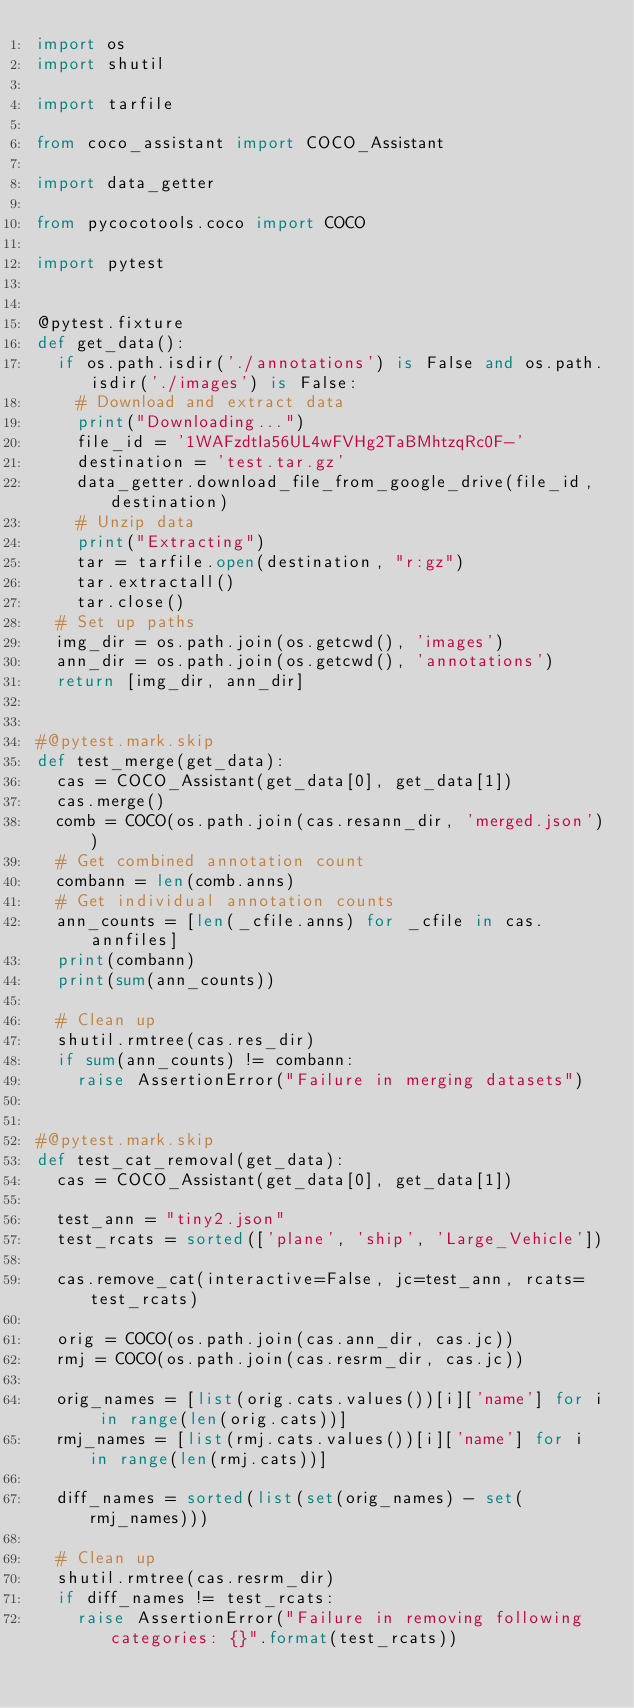<code> <loc_0><loc_0><loc_500><loc_500><_Python_>import os
import shutil

import tarfile

from coco_assistant import COCO_Assistant

import data_getter

from pycocotools.coco import COCO

import pytest


@pytest.fixture
def get_data():
	if os.path.isdir('./annotations') is False and os.path.isdir('./images') is False:
		# Download and extract data
		print("Downloading...")
		file_id = '1WAFzdtIa56UL4wFVHg2TaBMhtzqRc0F-'
		destination = 'test.tar.gz'
		data_getter.download_file_from_google_drive(file_id, destination)
		# Unzip data
		print("Extracting")
		tar = tarfile.open(destination, "r:gz")
		tar.extractall()
		tar.close()
	# Set up paths
	img_dir = os.path.join(os.getcwd(), 'images')
	ann_dir = os.path.join(os.getcwd(), 'annotations')
	return [img_dir, ann_dir]


#@pytest.mark.skip
def test_merge(get_data):
	cas = COCO_Assistant(get_data[0], get_data[1])
	cas.merge()
	comb = COCO(os.path.join(cas.resann_dir, 'merged.json'))
	# Get combined annotation count
	combann = len(comb.anns)
	# Get individual annotation counts
	ann_counts = [len(_cfile.anns) for _cfile in cas.annfiles]
	print(combann)
	print(sum(ann_counts))

	# Clean up
	shutil.rmtree(cas.res_dir)
	if sum(ann_counts) != combann:
		raise AssertionError("Failure in merging datasets")


#@pytest.mark.skip
def test_cat_removal(get_data):
	cas = COCO_Assistant(get_data[0], get_data[1])

	test_ann = "tiny2.json"
	test_rcats = sorted(['plane', 'ship', 'Large_Vehicle'])

	cas.remove_cat(interactive=False, jc=test_ann, rcats=test_rcats)

	orig = COCO(os.path.join(cas.ann_dir, cas.jc))
	rmj = COCO(os.path.join(cas.resrm_dir, cas.jc))

	orig_names = [list(orig.cats.values())[i]['name'] for i in range(len(orig.cats))]
	rmj_names = [list(rmj.cats.values())[i]['name'] for i in range(len(rmj.cats))]

	diff_names = sorted(list(set(orig_names) - set(rmj_names)))

	# Clean up
	shutil.rmtree(cas.resrm_dir)
	if diff_names != test_rcats:
		raise AssertionError("Failure in removing following categories: {}".format(test_rcats))
</code> 